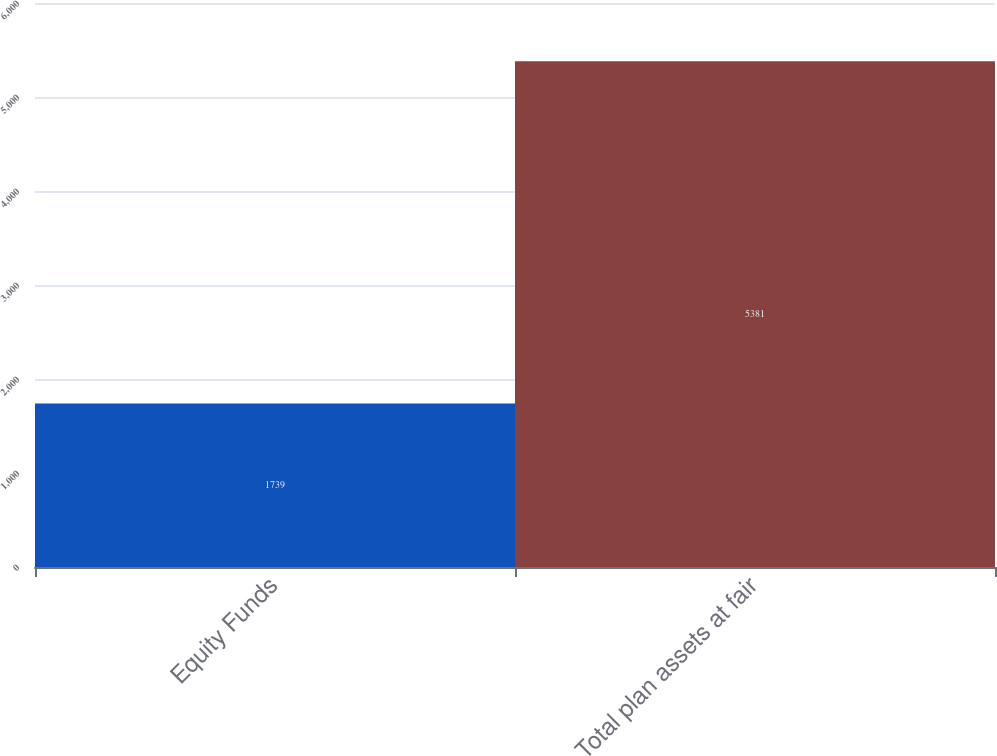<chart> <loc_0><loc_0><loc_500><loc_500><bar_chart><fcel>Equity Funds<fcel>Total plan assets at fair<nl><fcel>1739<fcel>5381<nl></chart> 